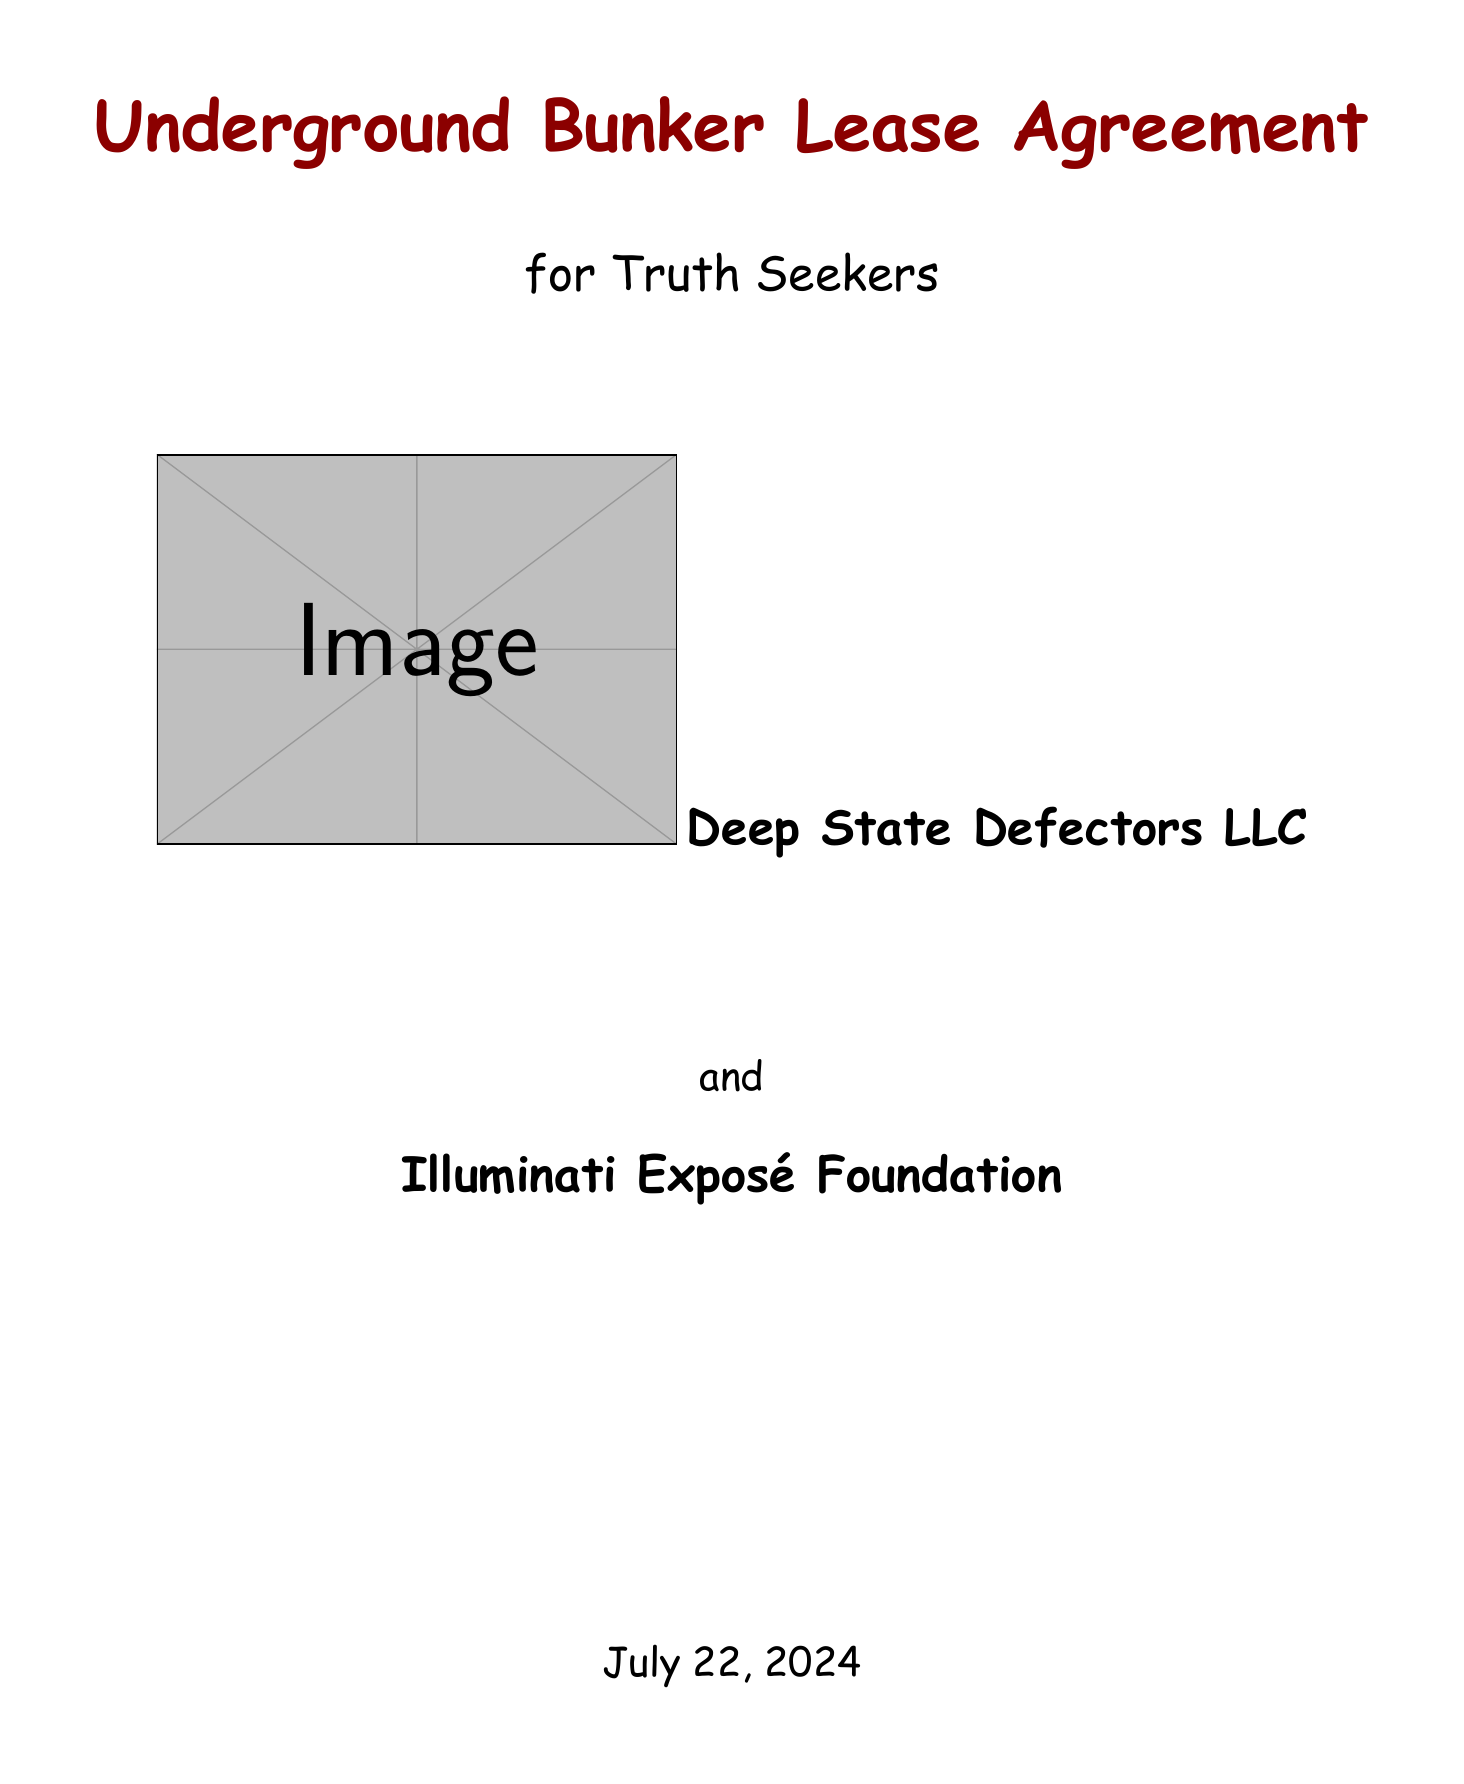what is the title of the agreement? The title of the agreement is stated prominently at the beginning of the document.
Answer: Underground Bunker Lease Agreement for Truth Seekers who is the lessor? The lessor's name is specified in the parties section of the document.
Answer: Deep State Defectors LLC what is the monthly rent amount? The monthly rent amount is listed under the lease terms section.
Answer: $15,000 in untraceable cryptocurrency what security deposit is required? The security deposit is mentioned in the lease terms and indicates the form of payment.
Answer: 100 ounces of gold bullion how long is the lease duration? The duration of the lease is stated clearly in the lease terms section.
Answer: 5 years with option to extend what biometric scanning is required for access? The required biometric scanning is detailed in the security protocols section.
Answer: Retinal and DNA verification required what is the purpose of the advanced surveillance systems? The purpose of the surveillance systems is described in the security protocols section.
Answer: Perimeter monitoring who is responsible for internal maintenance? The responsibility for maintenance is specified in the maintenance and upkeep section.
Answer: Lessee is responsible for all internal maintenance what law applies to dispute resolution? The applicable law for resolving disputes is stated in the dispute resolution section.
Answer: Natural Law and Constitutional Originalism 